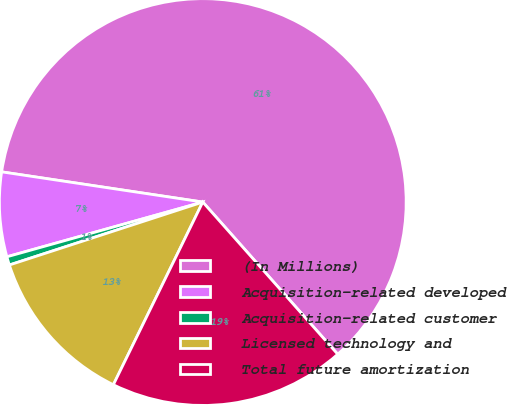Convert chart to OTSL. <chart><loc_0><loc_0><loc_500><loc_500><pie_chart><fcel>(In Millions)<fcel>Acquisition-related developed<fcel>Acquisition-related customer<fcel>Licensed technology and<fcel>Total future amortization<nl><fcel>61.09%<fcel>6.71%<fcel>0.67%<fcel>12.75%<fcel>18.79%<nl></chart> 